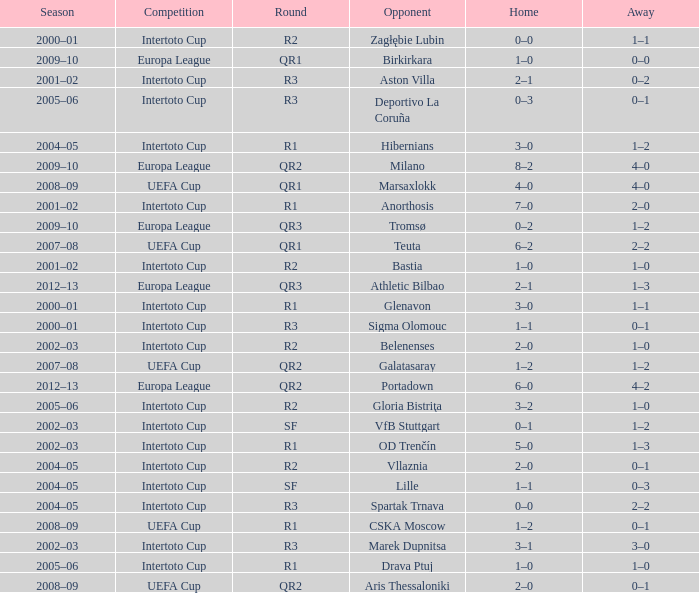What is the home score with marek dupnitsa as opponent? 3–1. 